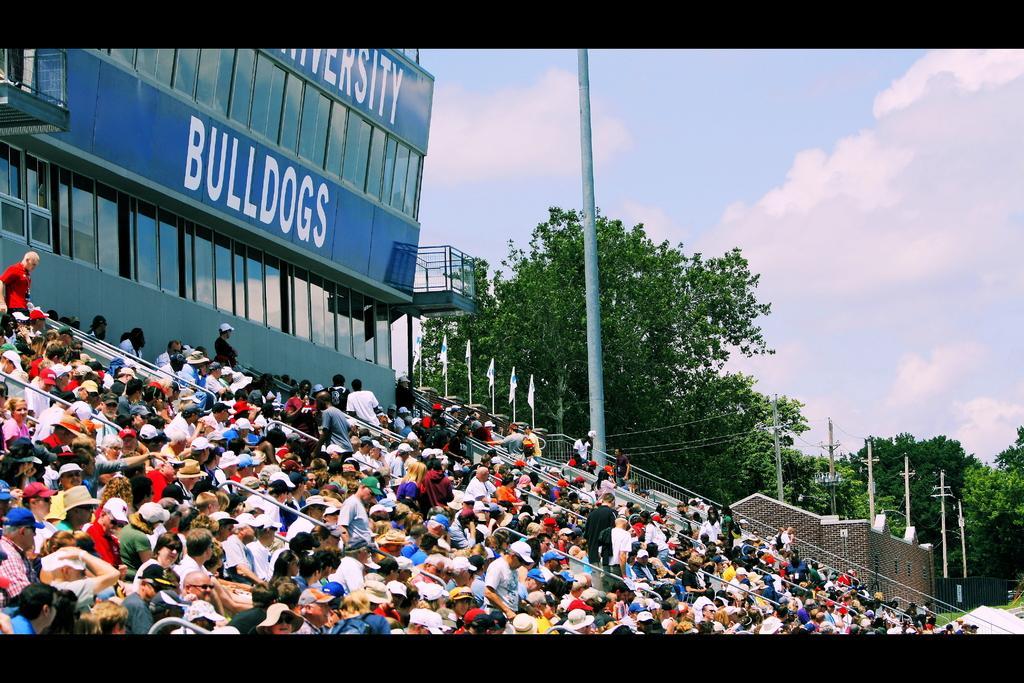Can you describe this image briefly? In this image we can see a group of people sitting and behind them there is a building with some text, beside it there are flags, compound wall, current polls, railing and some trees. 